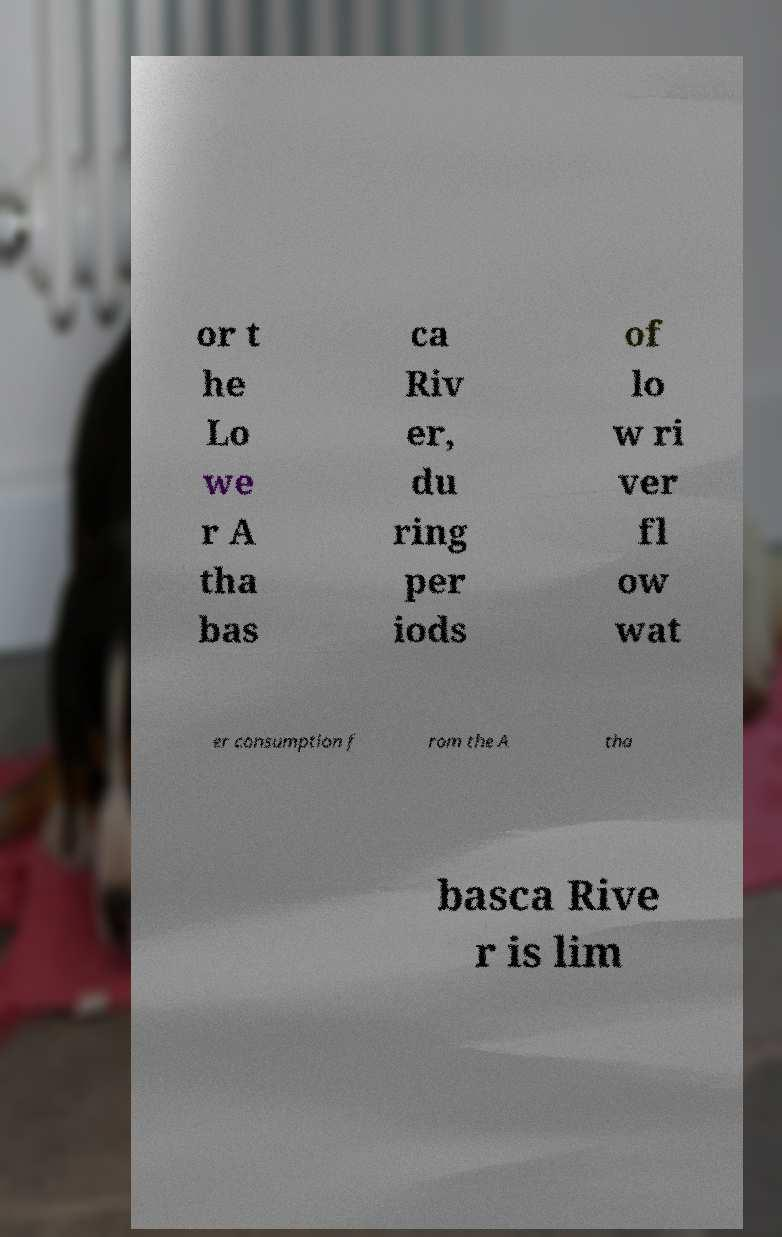What messages or text are displayed in this image? I need them in a readable, typed format. or t he Lo we r A tha bas ca Riv er, du ring per iods of lo w ri ver fl ow wat er consumption f rom the A tha basca Rive r is lim 